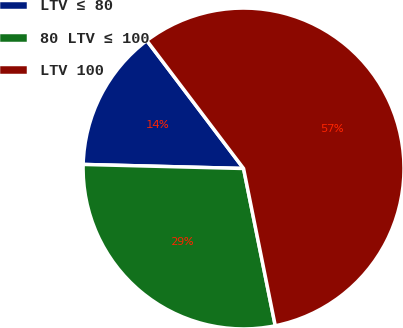<chart> <loc_0><loc_0><loc_500><loc_500><pie_chart><fcel>LTV ≤ 80<fcel>80 LTV ≤ 100<fcel>LTV 100<nl><fcel>14.29%<fcel>28.57%<fcel>57.14%<nl></chart> 